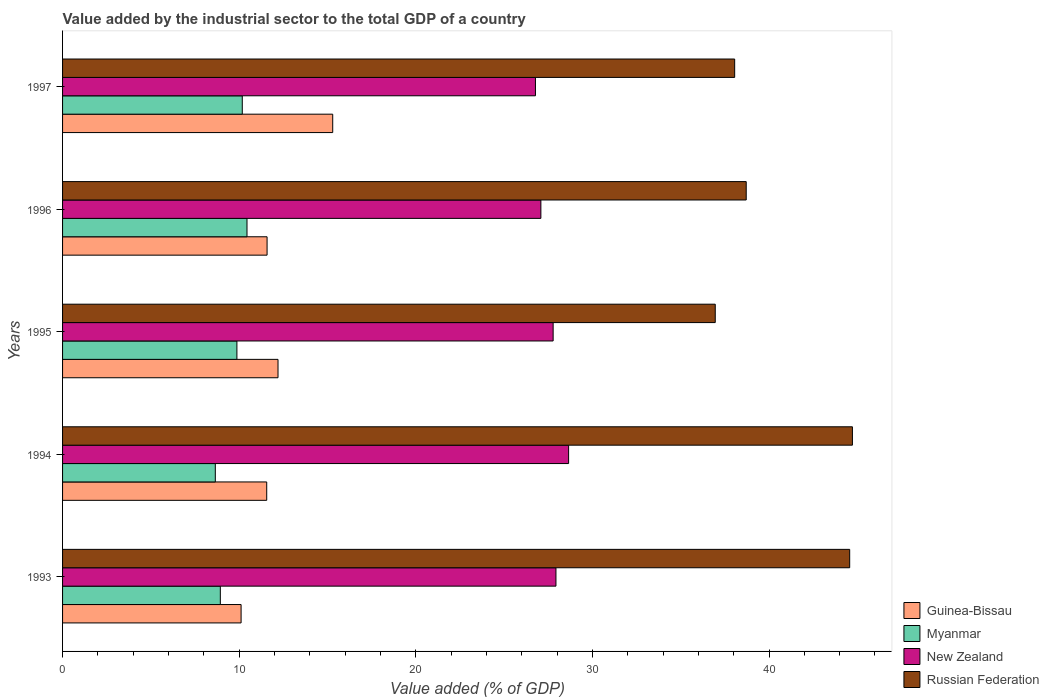How many different coloured bars are there?
Give a very brief answer. 4. Are the number of bars per tick equal to the number of legend labels?
Give a very brief answer. Yes. Are the number of bars on each tick of the Y-axis equal?
Provide a short and direct response. Yes. How many bars are there on the 4th tick from the top?
Ensure brevity in your answer.  4. What is the label of the 5th group of bars from the top?
Offer a very short reply. 1993. What is the value added by the industrial sector to the total GDP in Russian Federation in 1994?
Ensure brevity in your answer.  44.72. Across all years, what is the maximum value added by the industrial sector to the total GDP in Myanmar?
Provide a short and direct response. 10.44. Across all years, what is the minimum value added by the industrial sector to the total GDP in New Zealand?
Offer a terse response. 26.78. In which year was the value added by the industrial sector to the total GDP in New Zealand maximum?
Provide a succinct answer. 1994. In which year was the value added by the industrial sector to the total GDP in Guinea-Bissau minimum?
Offer a very short reply. 1993. What is the total value added by the industrial sector to the total GDP in Russian Federation in the graph?
Keep it short and to the point. 203.01. What is the difference between the value added by the industrial sector to the total GDP in Russian Federation in 1993 and that in 1995?
Your response must be concise. 7.61. What is the difference between the value added by the industrial sector to the total GDP in Myanmar in 1994 and the value added by the industrial sector to the total GDP in Guinea-Bissau in 1997?
Give a very brief answer. -6.65. What is the average value added by the industrial sector to the total GDP in Guinea-Bissau per year?
Offer a terse response. 12.15. In the year 1996, what is the difference between the value added by the industrial sector to the total GDP in Myanmar and value added by the industrial sector to the total GDP in Russian Federation?
Provide a succinct answer. -28.27. In how many years, is the value added by the industrial sector to the total GDP in Myanmar greater than 12 %?
Offer a terse response. 0. What is the ratio of the value added by the industrial sector to the total GDP in New Zealand in 1994 to that in 1996?
Make the answer very short. 1.06. Is the value added by the industrial sector to the total GDP in New Zealand in 1995 less than that in 1996?
Offer a terse response. No. What is the difference between the highest and the second highest value added by the industrial sector to the total GDP in Russian Federation?
Make the answer very short. 0.15. What is the difference between the highest and the lowest value added by the industrial sector to the total GDP in Myanmar?
Provide a short and direct response. 1.79. Is it the case that in every year, the sum of the value added by the industrial sector to the total GDP in Guinea-Bissau and value added by the industrial sector to the total GDP in New Zealand is greater than the sum of value added by the industrial sector to the total GDP in Myanmar and value added by the industrial sector to the total GDP in Russian Federation?
Provide a short and direct response. No. What does the 4th bar from the top in 1993 represents?
Offer a terse response. Guinea-Bissau. What does the 2nd bar from the bottom in 1996 represents?
Offer a very short reply. Myanmar. Is it the case that in every year, the sum of the value added by the industrial sector to the total GDP in New Zealand and value added by the industrial sector to the total GDP in Guinea-Bissau is greater than the value added by the industrial sector to the total GDP in Myanmar?
Offer a very short reply. Yes. Are all the bars in the graph horizontal?
Make the answer very short. Yes. How many years are there in the graph?
Make the answer very short. 5. Are the values on the major ticks of X-axis written in scientific E-notation?
Your answer should be compact. No. Does the graph contain grids?
Keep it short and to the point. No. Where does the legend appear in the graph?
Your answer should be very brief. Bottom right. How many legend labels are there?
Offer a very short reply. 4. What is the title of the graph?
Your answer should be very brief. Value added by the industrial sector to the total GDP of a country. What is the label or title of the X-axis?
Provide a short and direct response. Value added (% of GDP). What is the Value added (% of GDP) in Guinea-Bissau in 1993?
Make the answer very short. 10.11. What is the Value added (% of GDP) in Myanmar in 1993?
Make the answer very short. 8.93. What is the Value added (% of GDP) in New Zealand in 1993?
Provide a short and direct response. 27.94. What is the Value added (% of GDP) of Russian Federation in 1993?
Make the answer very short. 44.57. What is the Value added (% of GDP) of Guinea-Bissau in 1994?
Keep it short and to the point. 11.56. What is the Value added (% of GDP) in Myanmar in 1994?
Your answer should be very brief. 8.65. What is the Value added (% of GDP) in New Zealand in 1994?
Make the answer very short. 28.65. What is the Value added (% of GDP) in Russian Federation in 1994?
Offer a terse response. 44.72. What is the Value added (% of GDP) of Guinea-Bissau in 1995?
Ensure brevity in your answer.  12.2. What is the Value added (% of GDP) in Myanmar in 1995?
Give a very brief answer. 9.87. What is the Value added (% of GDP) in New Zealand in 1995?
Offer a very short reply. 27.78. What is the Value added (% of GDP) of Russian Federation in 1995?
Your answer should be compact. 36.96. What is the Value added (% of GDP) in Guinea-Bissau in 1996?
Make the answer very short. 11.58. What is the Value added (% of GDP) of Myanmar in 1996?
Make the answer very short. 10.44. What is the Value added (% of GDP) of New Zealand in 1996?
Provide a succinct answer. 27.08. What is the Value added (% of GDP) of Russian Federation in 1996?
Offer a terse response. 38.71. What is the Value added (% of GDP) in Guinea-Bissau in 1997?
Offer a very short reply. 15.3. What is the Value added (% of GDP) in Myanmar in 1997?
Give a very brief answer. 10.18. What is the Value added (% of GDP) of New Zealand in 1997?
Your answer should be compact. 26.78. What is the Value added (% of GDP) of Russian Federation in 1997?
Your answer should be compact. 38.06. Across all years, what is the maximum Value added (% of GDP) in Guinea-Bissau?
Offer a very short reply. 15.3. Across all years, what is the maximum Value added (% of GDP) in Myanmar?
Make the answer very short. 10.44. Across all years, what is the maximum Value added (% of GDP) of New Zealand?
Your answer should be compact. 28.65. Across all years, what is the maximum Value added (% of GDP) of Russian Federation?
Ensure brevity in your answer.  44.72. Across all years, what is the minimum Value added (% of GDP) of Guinea-Bissau?
Offer a very short reply. 10.11. Across all years, what is the minimum Value added (% of GDP) in Myanmar?
Offer a terse response. 8.65. Across all years, what is the minimum Value added (% of GDP) of New Zealand?
Provide a succinct answer. 26.78. Across all years, what is the minimum Value added (% of GDP) of Russian Federation?
Offer a very short reply. 36.96. What is the total Value added (% of GDP) of Guinea-Bissau in the graph?
Your response must be concise. 60.74. What is the total Value added (% of GDP) in Myanmar in the graph?
Offer a very short reply. 48.07. What is the total Value added (% of GDP) of New Zealand in the graph?
Your answer should be very brief. 138.22. What is the total Value added (% of GDP) of Russian Federation in the graph?
Provide a short and direct response. 203.01. What is the difference between the Value added (% of GDP) of Guinea-Bissau in 1993 and that in 1994?
Your response must be concise. -1.45. What is the difference between the Value added (% of GDP) of Myanmar in 1993 and that in 1994?
Your answer should be very brief. 0.28. What is the difference between the Value added (% of GDP) of New Zealand in 1993 and that in 1994?
Provide a succinct answer. -0.72. What is the difference between the Value added (% of GDP) of Russian Federation in 1993 and that in 1994?
Offer a very short reply. -0.15. What is the difference between the Value added (% of GDP) in Guinea-Bissau in 1993 and that in 1995?
Make the answer very short. -2.09. What is the difference between the Value added (% of GDP) of Myanmar in 1993 and that in 1995?
Your response must be concise. -0.94. What is the difference between the Value added (% of GDP) of New Zealand in 1993 and that in 1995?
Your answer should be compact. 0.16. What is the difference between the Value added (% of GDP) of Russian Federation in 1993 and that in 1995?
Offer a very short reply. 7.61. What is the difference between the Value added (% of GDP) in Guinea-Bissau in 1993 and that in 1996?
Ensure brevity in your answer.  -1.47. What is the difference between the Value added (% of GDP) of Myanmar in 1993 and that in 1996?
Make the answer very short. -1.51. What is the difference between the Value added (% of GDP) of New Zealand in 1993 and that in 1996?
Keep it short and to the point. 0.85. What is the difference between the Value added (% of GDP) of Russian Federation in 1993 and that in 1996?
Provide a succinct answer. 5.86. What is the difference between the Value added (% of GDP) of Guinea-Bissau in 1993 and that in 1997?
Your answer should be very brief. -5.19. What is the difference between the Value added (% of GDP) of Myanmar in 1993 and that in 1997?
Give a very brief answer. -1.24. What is the difference between the Value added (% of GDP) of New Zealand in 1993 and that in 1997?
Give a very brief answer. 1.16. What is the difference between the Value added (% of GDP) of Russian Federation in 1993 and that in 1997?
Make the answer very short. 6.51. What is the difference between the Value added (% of GDP) in Guinea-Bissau in 1994 and that in 1995?
Provide a succinct answer. -0.64. What is the difference between the Value added (% of GDP) of Myanmar in 1994 and that in 1995?
Keep it short and to the point. -1.22. What is the difference between the Value added (% of GDP) in New Zealand in 1994 and that in 1995?
Make the answer very short. 0.88. What is the difference between the Value added (% of GDP) in Russian Federation in 1994 and that in 1995?
Your response must be concise. 7.77. What is the difference between the Value added (% of GDP) in Guinea-Bissau in 1994 and that in 1996?
Offer a very short reply. -0.02. What is the difference between the Value added (% of GDP) in Myanmar in 1994 and that in 1996?
Your response must be concise. -1.79. What is the difference between the Value added (% of GDP) of New Zealand in 1994 and that in 1996?
Offer a terse response. 1.57. What is the difference between the Value added (% of GDP) in Russian Federation in 1994 and that in 1996?
Ensure brevity in your answer.  6.01. What is the difference between the Value added (% of GDP) in Guinea-Bissau in 1994 and that in 1997?
Your answer should be compact. -3.74. What is the difference between the Value added (% of GDP) in Myanmar in 1994 and that in 1997?
Make the answer very short. -1.53. What is the difference between the Value added (% of GDP) of New Zealand in 1994 and that in 1997?
Your answer should be compact. 1.88. What is the difference between the Value added (% of GDP) in Russian Federation in 1994 and that in 1997?
Your response must be concise. 6.67. What is the difference between the Value added (% of GDP) in Guinea-Bissau in 1995 and that in 1996?
Give a very brief answer. 0.62. What is the difference between the Value added (% of GDP) of Myanmar in 1995 and that in 1996?
Provide a succinct answer. -0.57. What is the difference between the Value added (% of GDP) of New Zealand in 1995 and that in 1996?
Make the answer very short. 0.69. What is the difference between the Value added (% of GDP) in Russian Federation in 1995 and that in 1996?
Give a very brief answer. -1.75. What is the difference between the Value added (% of GDP) of Guinea-Bissau in 1995 and that in 1997?
Offer a terse response. -3.1. What is the difference between the Value added (% of GDP) of Myanmar in 1995 and that in 1997?
Your answer should be compact. -0.3. What is the difference between the Value added (% of GDP) of New Zealand in 1995 and that in 1997?
Make the answer very short. 1. What is the difference between the Value added (% of GDP) of Russian Federation in 1995 and that in 1997?
Your answer should be very brief. -1.1. What is the difference between the Value added (% of GDP) in Guinea-Bissau in 1996 and that in 1997?
Your response must be concise. -3.72. What is the difference between the Value added (% of GDP) of Myanmar in 1996 and that in 1997?
Provide a short and direct response. 0.27. What is the difference between the Value added (% of GDP) of New Zealand in 1996 and that in 1997?
Offer a very short reply. 0.31. What is the difference between the Value added (% of GDP) of Russian Federation in 1996 and that in 1997?
Offer a terse response. 0.65. What is the difference between the Value added (% of GDP) of Guinea-Bissau in 1993 and the Value added (% of GDP) of Myanmar in 1994?
Your response must be concise. 1.46. What is the difference between the Value added (% of GDP) of Guinea-Bissau in 1993 and the Value added (% of GDP) of New Zealand in 1994?
Provide a short and direct response. -18.54. What is the difference between the Value added (% of GDP) of Guinea-Bissau in 1993 and the Value added (% of GDP) of Russian Federation in 1994?
Give a very brief answer. -34.61. What is the difference between the Value added (% of GDP) of Myanmar in 1993 and the Value added (% of GDP) of New Zealand in 1994?
Keep it short and to the point. -19.72. What is the difference between the Value added (% of GDP) in Myanmar in 1993 and the Value added (% of GDP) in Russian Federation in 1994?
Ensure brevity in your answer.  -35.79. What is the difference between the Value added (% of GDP) in New Zealand in 1993 and the Value added (% of GDP) in Russian Federation in 1994?
Provide a succinct answer. -16.79. What is the difference between the Value added (% of GDP) in Guinea-Bissau in 1993 and the Value added (% of GDP) in Myanmar in 1995?
Offer a terse response. 0.24. What is the difference between the Value added (% of GDP) of Guinea-Bissau in 1993 and the Value added (% of GDP) of New Zealand in 1995?
Keep it short and to the point. -17.67. What is the difference between the Value added (% of GDP) in Guinea-Bissau in 1993 and the Value added (% of GDP) in Russian Federation in 1995?
Provide a short and direct response. -26.85. What is the difference between the Value added (% of GDP) of Myanmar in 1993 and the Value added (% of GDP) of New Zealand in 1995?
Make the answer very short. -18.84. What is the difference between the Value added (% of GDP) of Myanmar in 1993 and the Value added (% of GDP) of Russian Federation in 1995?
Ensure brevity in your answer.  -28.02. What is the difference between the Value added (% of GDP) of New Zealand in 1993 and the Value added (% of GDP) of Russian Federation in 1995?
Provide a short and direct response. -9.02. What is the difference between the Value added (% of GDP) of Guinea-Bissau in 1993 and the Value added (% of GDP) of Myanmar in 1996?
Offer a very short reply. -0.33. What is the difference between the Value added (% of GDP) of Guinea-Bissau in 1993 and the Value added (% of GDP) of New Zealand in 1996?
Offer a terse response. -16.97. What is the difference between the Value added (% of GDP) in Guinea-Bissau in 1993 and the Value added (% of GDP) in Russian Federation in 1996?
Keep it short and to the point. -28.6. What is the difference between the Value added (% of GDP) of Myanmar in 1993 and the Value added (% of GDP) of New Zealand in 1996?
Give a very brief answer. -18.15. What is the difference between the Value added (% of GDP) of Myanmar in 1993 and the Value added (% of GDP) of Russian Federation in 1996?
Offer a very short reply. -29.78. What is the difference between the Value added (% of GDP) in New Zealand in 1993 and the Value added (% of GDP) in Russian Federation in 1996?
Your response must be concise. -10.77. What is the difference between the Value added (% of GDP) of Guinea-Bissau in 1993 and the Value added (% of GDP) of Myanmar in 1997?
Offer a very short reply. -0.07. What is the difference between the Value added (% of GDP) in Guinea-Bissau in 1993 and the Value added (% of GDP) in New Zealand in 1997?
Provide a short and direct response. -16.67. What is the difference between the Value added (% of GDP) of Guinea-Bissau in 1993 and the Value added (% of GDP) of Russian Federation in 1997?
Keep it short and to the point. -27.95. What is the difference between the Value added (% of GDP) in Myanmar in 1993 and the Value added (% of GDP) in New Zealand in 1997?
Your response must be concise. -17.84. What is the difference between the Value added (% of GDP) in Myanmar in 1993 and the Value added (% of GDP) in Russian Federation in 1997?
Give a very brief answer. -29.12. What is the difference between the Value added (% of GDP) in New Zealand in 1993 and the Value added (% of GDP) in Russian Federation in 1997?
Your answer should be very brief. -10.12. What is the difference between the Value added (% of GDP) of Guinea-Bissau in 1994 and the Value added (% of GDP) of Myanmar in 1995?
Ensure brevity in your answer.  1.69. What is the difference between the Value added (% of GDP) in Guinea-Bissau in 1994 and the Value added (% of GDP) in New Zealand in 1995?
Provide a succinct answer. -16.22. What is the difference between the Value added (% of GDP) of Guinea-Bissau in 1994 and the Value added (% of GDP) of Russian Federation in 1995?
Offer a terse response. -25.4. What is the difference between the Value added (% of GDP) in Myanmar in 1994 and the Value added (% of GDP) in New Zealand in 1995?
Offer a terse response. -19.13. What is the difference between the Value added (% of GDP) of Myanmar in 1994 and the Value added (% of GDP) of Russian Federation in 1995?
Provide a short and direct response. -28.31. What is the difference between the Value added (% of GDP) in New Zealand in 1994 and the Value added (% of GDP) in Russian Federation in 1995?
Keep it short and to the point. -8.3. What is the difference between the Value added (% of GDP) in Guinea-Bissau in 1994 and the Value added (% of GDP) in Myanmar in 1996?
Your answer should be very brief. 1.12. What is the difference between the Value added (% of GDP) in Guinea-Bissau in 1994 and the Value added (% of GDP) in New Zealand in 1996?
Make the answer very short. -15.52. What is the difference between the Value added (% of GDP) in Guinea-Bissau in 1994 and the Value added (% of GDP) in Russian Federation in 1996?
Provide a succinct answer. -27.15. What is the difference between the Value added (% of GDP) in Myanmar in 1994 and the Value added (% of GDP) in New Zealand in 1996?
Provide a succinct answer. -18.43. What is the difference between the Value added (% of GDP) of Myanmar in 1994 and the Value added (% of GDP) of Russian Federation in 1996?
Provide a short and direct response. -30.06. What is the difference between the Value added (% of GDP) in New Zealand in 1994 and the Value added (% of GDP) in Russian Federation in 1996?
Your answer should be very brief. -10.06. What is the difference between the Value added (% of GDP) of Guinea-Bissau in 1994 and the Value added (% of GDP) of Myanmar in 1997?
Ensure brevity in your answer.  1.38. What is the difference between the Value added (% of GDP) of Guinea-Bissau in 1994 and the Value added (% of GDP) of New Zealand in 1997?
Offer a very short reply. -15.22. What is the difference between the Value added (% of GDP) in Guinea-Bissau in 1994 and the Value added (% of GDP) in Russian Federation in 1997?
Provide a short and direct response. -26.5. What is the difference between the Value added (% of GDP) of Myanmar in 1994 and the Value added (% of GDP) of New Zealand in 1997?
Your answer should be very brief. -18.13. What is the difference between the Value added (% of GDP) in Myanmar in 1994 and the Value added (% of GDP) in Russian Federation in 1997?
Provide a succinct answer. -29.41. What is the difference between the Value added (% of GDP) in New Zealand in 1994 and the Value added (% of GDP) in Russian Federation in 1997?
Your answer should be compact. -9.4. What is the difference between the Value added (% of GDP) in Guinea-Bissau in 1995 and the Value added (% of GDP) in Myanmar in 1996?
Provide a succinct answer. 1.76. What is the difference between the Value added (% of GDP) of Guinea-Bissau in 1995 and the Value added (% of GDP) of New Zealand in 1996?
Your answer should be compact. -14.88. What is the difference between the Value added (% of GDP) of Guinea-Bissau in 1995 and the Value added (% of GDP) of Russian Federation in 1996?
Keep it short and to the point. -26.51. What is the difference between the Value added (% of GDP) in Myanmar in 1995 and the Value added (% of GDP) in New Zealand in 1996?
Give a very brief answer. -17.21. What is the difference between the Value added (% of GDP) of Myanmar in 1995 and the Value added (% of GDP) of Russian Federation in 1996?
Your response must be concise. -28.84. What is the difference between the Value added (% of GDP) of New Zealand in 1995 and the Value added (% of GDP) of Russian Federation in 1996?
Your answer should be compact. -10.93. What is the difference between the Value added (% of GDP) in Guinea-Bissau in 1995 and the Value added (% of GDP) in Myanmar in 1997?
Ensure brevity in your answer.  2.02. What is the difference between the Value added (% of GDP) of Guinea-Bissau in 1995 and the Value added (% of GDP) of New Zealand in 1997?
Offer a terse response. -14.58. What is the difference between the Value added (% of GDP) in Guinea-Bissau in 1995 and the Value added (% of GDP) in Russian Federation in 1997?
Keep it short and to the point. -25.86. What is the difference between the Value added (% of GDP) of Myanmar in 1995 and the Value added (% of GDP) of New Zealand in 1997?
Your answer should be very brief. -16.9. What is the difference between the Value added (% of GDP) in Myanmar in 1995 and the Value added (% of GDP) in Russian Federation in 1997?
Your answer should be very brief. -28.18. What is the difference between the Value added (% of GDP) of New Zealand in 1995 and the Value added (% of GDP) of Russian Federation in 1997?
Keep it short and to the point. -10.28. What is the difference between the Value added (% of GDP) in Guinea-Bissau in 1996 and the Value added (% of GDP) in Myanmar in 1997?
Offer a very short reply. 1.4. What is the difference between the Value added (% of GDP) of Guinea-Bissau in 1996 and the Value added (% of GDP) of New Zealand in 1997?
Provide a succinct answer. -15.2. What is the difference between the Value added (% of GDP) of Guinea-Bissau in 1996 and the Value added (% of GDP) of Russian Federation in 1997?
Your response must be concise. -26.48. What is the difference between the Value added (% of GDP) of Myanmar in 1996 and the Value added (% of GDP) of New Zealand in 1997?
Ensure brevity in your answer.  -16.33. What is the difference between the Value added (% of GDP) in Myanmar in 1996 and the Value added (% of GDP) in Russian Federation in 1997?
Ensure brevity in your answer.  -27.61. What is the difference between the Value added (% of GDP) of New Zealand in 1996 and the Value added (% of GDP) of Russian Federation in 1997?
Give a very brief answer. -10.97. What is the average Value added (% of GDP) in Guinea-Bissau per year?
Your response must be concise. 12.15. What is the average Value added (% of GDP) in Myanmar per year?
Your response must be concise. 9.61. What is the average Value added (% of GDP) in New Zealand per year?
Make the answer very short. 27.64. What is the average Value added (% of GDP) in Russian Federation per year?
Ensure brevity in your answer.  40.6. In the year 1993, what is the difference between the Value added (% of GDP) in Guinea-Bissau and Value added (% of GDP) in Myanmar?
Provide a short and direct response. 1.18. In the year 1993, what is the difference between the Value added (% of GDP) of Guinea-Bissau and Value added (% of GDP) of New Zealand?
Offer a terse response. -17.83. In the year 1993, what is the difference between the Value added (% of GDP) of Guinea-Bissau and Value added (% of GDP) of Russian Federation?
Your answer should be compact. -34.46. In the year 1993, what is the difference between the Value added (% of GDP) in Myanmar and Value added (% of GDP) in New Zealand?
Ensure brevity in your answer.  -19. In the year 1993, what is the difference between the Value added (% of GDP) in Myanmar and Value added (% of GDP) in Russian Federation?
Make the answer very short. -35.64. In the year 1993, what is the difference between the Value added (% of GDP) of New Zealand and Value added (% of GDP) of Russian Federation?
Your answer should be compact. -16.63. In the year 1994, what is the difference between the Value added (% of GDP) in Guinea-Bissau and Value added (% of GDP) in Myanmar?
Provide a short and direct response. 2.91. In the year 1994, what is the difference between the Value added (% of GDP) in Guinea-Bissau and Value added (% of GDP) in New Zealand?
Your answer should be compact. -17.09. In the year 1994, what is the difference between the Value added (% of GDP) in Guinea-Bissau and Value added (% of GDP) in Russian Federation?
Give a very brief answer. -33.16. In the year 1994, what is the difference between the Value added (% of GDP) of Myanmar and Value added (% of GDP) of New Zealand?
Offer a very short reply. -20. In the year 1994, what is the difference between the Value added (% of GDP) of Myanmar and Value added (% of GDP) of Russian Federation?
Your response must be concise. -36.07. In the year 1994, what is the difference between the Value added (% of GDP) of New Zealand and Value added (% of GDP) of Russian Federation?
Provide a short and direct response. -16.07. In the year 1995, what is the difference between the Value added (% of GDP) in Guinea-Bissau and Value added (% of GDP) in Myanmar?
Offer a terse response. 2.33. In the year 1995, what is the difference between the Value added (% of GDP) of Guinea-Bissau and Value added (% of GDP) of New Zealand?
Ensure brevity in your answer.  -15.58. In the year 1995, what is the difference between the Value added (% of GDP) of Guinea-Bissau and Value added (% of GDP) of Russian Federation?
Offer a terse response. -24.76. In the year 1995, what is the difference between the Value added (% of GDP) of Myanmar and Value added (% of GDP) of New Zealand?
Your answer should be very brief. -17.91. In the year 1995, what is the difference between the Value added (% of GDP) in Myanmar and Value added (% of GDP) in Russian Federation?
Make the answer very short. -27.09. In the year 1995, what is the difference between the Value added (% of GDP) of New Zealand and Value added (% of GDP) of Russian Federation?
Make the answer very short. -9.18. In the year 1996, what is the difference between the Value added (% of GDP) of Guinea-Bissau and Value added (% of GDP) of Myanmar?
Your response must be concise. 1.14. In the year 1996, what is the difference between the Value added (% of GDP) in Guinea-Bissau and Value added (% of GDP) in New Zealand?
Your response must be concise. -15.5. In the year 1996, what is the difference between the Value added (% of GDP) in Guinea-Bissau and Value added (% of GDP) in Russian Federation?
Your response must be concise. -27.13. In the year 1996, what is the difference between the Value added (% of GDP) of Myanmar and Value added (% of GDP) of New Zealand?
Your answer should be very brief. -16.64. In the year 1996, what is the difference between the Value added (% of GDP) in Myanmar and Value added (% of GDP) in Russian Federation?
Provide a short and direct response. -28.27. In the year 1996, what is the difference between the Value added (% of GDP) of New Zealand and Value added (% of GDP) of Russian Federation?
Give a very brief answer. -11.63. In the year 1997, what is the difference between the Value added (% of GDP) in Guinea-Bissau and Value added (% of GDP) in Myanmar?
Your answer should be very brief. 5.12. In the year 1997, what is the difference between the Value added (% of GDP) of Guinea-Bissau and Value added (% of GDP) of New Zealand?
Provide a succinct answer. -11.48. In the year 1997, what is the difference between the Value added (% of GDP) in Guinea-Bissau and Value added (% of GDP) in Russian Federation?
Ensure brevity in your answer.  -22.76. In the year 1997, what is the difference between the Value added (% of GDP) of Myanmar and Value added (% of GDP) of New Zealand?
Give a very brief answer. -16.6. In the year 1997, what is the difference between the Value added (% of GDP) of Myanmar and Value added (% of GDP) of Russian Federation?
Provide a succinct answer. -27.88. In the year 1997, what is the difference between the Value added (% of GDP) of New Zealand and Value added (% of GDP) of Russian Federation?
Offer a very short reply. -11.28. What is the ratio of the Value added (% of GDP) of Guinea-Bissau in 1993 to that in 1994?
Your response must be concise. 0.87. What is the ratio of the Value added (% of GDP) in Myanmar in 1993 to that in 1994?
Your answer should be very brief. 1.03. What is the ratio of the Value added (% of GDP) in New Zealand in 1993 to that in 1994?
Make the answer very short. 0.97. What is the ratio of the Value added (% of GDP) of Russian Federation in 1993 to that in 1994?
Provide a short and direct response. 1. What is the ratio of the Value added (% of GDP) of Guinea-Bissau in 1993 to that in 1995?
Offer a very short reply. 0.83. What is the ratio of the Value added (% of GDP) of Myanmar in 1993 to that in 1995?
Provide a short and direct response. 0.9. What is the ratio of the Value added (% of GDP) of Russian Federation in 1993 to that in 1995?
Give a very brief answer. 1.21. What is the ratio of the Value added (% of GDP) of Guinea-Bissau in 1993 to that in 1996?
Ensure brevity in your answer.  0.87. What is the ratio of the Value added (% of GDP) in Myanmar in 1993 to that in 1996?
Provide a succinct answer. 0.86. What is the ratio of the Value added (% of GDP) of New Zealand in 1993 to that in 1996?
Offer a terse response. 1.03. What is the ratio of the Value added (% of GDP) of Russian Federation in 1993 to that in 1996?
Offer a very short reply. 1.15. What is the ratio of the Value added (% of GDP) in Guinea-Bissau in 1993 to that in 1997?
Your response must be concise. 0.66. What is the ratio of the Value added (% of GDP) of Myanmar in 1993 to that in 1997?
Your answer should be very brief. 0.88. What is the ratio of the Value added (% of GDP) in New Zealand in 1993 to that in 1997?
Offer a very short reply. 1.04. What is the ratio of the Value added (% of GDP) in Russian Federation in 1993 to that in 1997?
Offer a very short reply. 1.17. What is the ratio of the Value added (% of GDP) of Guinea-Bissau in 1994 to that in 1995?
Your answer should be very brief. 0.95. What is the ratio of the Value added (% of GDP) of Myanmar in 1994 to that in 1995?
Ensure brevity in your answer.  0.88. What is the ratio of the Value added (% of GDP) in New Zealand in 1994 to that in 1995?
Keep it short and to the point. 1.03. What is the ratio of the Value added (% of GDP) of Russian Federation in 1994 to that in 1995?
Offer a terse response. 1.21. What is the ratio of the Value added (% of GDP) of Myanmar in 1994 to that in 1996?
Provide a succinct answer. 0.83. What is the ratio of the Value added (% of GDP) of New Zealand in 1994 to that in 1996?
Make the answer very short. 1.06. What is the ratio of the Value added (% of GDP) in Russian Federation in 1994 to that in 1996?
Keep it short and to the point. 1.16. What is the ratio of the Value added (% of GDP) in Guinea-Bissau in 1994 to that in 1997?
Ensure brevity in your answer.  0.76. What is the ratio of the Value added (% of GDP) of New Zealand in 1994 to that in 1997?
Your answer should be very brief. 1.07. What is the ratio of the Value added (% of GDP) in Russian Federation in 1994 to that in 1997?
Offer a terse response. 1.18. What is the ratio of the Value added (% of GDP) in Guinea-Bissau in 1995 to that in 1996?
Your answer should be compact. 1.05. What is the ratio of the Value added (% of GDP) of Myanmar in 1995 to that in 1996?
Offer a terse response. 0.95. What is the ratio of the Value added (% of GDP) of New Zealand in 1995 to that in 1996?
Ensure brevity in your answer.  1.03. What is the ratio of the Value added (% of GDP) in Russian Federation in 1995 to that in 1996?
Your answer should be very brief. 0.95. What is the ratio of the Value added (% of GDP) in Guinea-Bissau in 1995 to that in 1997?
Offer a very short reply. 0.8. What is the ratio of the Value added (% of GDP) of Myanmar in 1995 to that in 1997?
Give a very brief answer. 0.97. What is the ratio of the Value added (% of GDP) in New Zealand in 1995 to that in 1997?
Ensure brevity in your answer.  1.04. What is the ratio of the Value added (% of GDP) of Russian Federation in 1995 to that in 1997?
Offer a terse response. 0.97. What is the ratio of the Value added (% of GDP) in Guinea-Bissau in 1996 to that in 1997?
Your response must be concise. 0.76. What is the ratio of the Value added (% of GDP) in Myanmar in 1996 to that in 1997?
Make the answer very short. 1.03. What is the ratio of the Value added (% of GDP) in New Zealand in 1996 to that in 1997?
Your answer should be very brief. 1.01. What is the ratio of the Value added (% of GDP) of Russian Federation in 1996 to that in 1997?
Keep it short and to the point. 1.02. What is the difference between the highest and the second highest Value added (% of GDP) of Guinea-Bissau?
Give a very brief answer. 3.1. What is the difference between the highest and the second highest Value added (% of GDP) of Myanmar?
Make the answer very short. 0.27. What is the difference between the highest and the second highest Value added (% of GDP) in New Zealand?
Give a very brief answer. 0.72. What is the difference between the highest and the second highest Value added (% of GDP) of Russian Federation?
Your answer should be compact. 0.15. What is the difference between the highest and the lowest Value added (% of GDP) of Guinea-Bissau?
Offer a terse response. 5.19. What is the difference between the highest and the lowest Value added (% of GDP) in Myanmar?
Provide a succinct answer. 1.79. What is the difference between the highest and the lowest Value added (% of GDP) in New Zealand?
Your response must be concise. 1.88. What is the difference between the highest and the lowest Value added (% of GDP) of Russian Federation?
Offer a terse response. 7.77. 